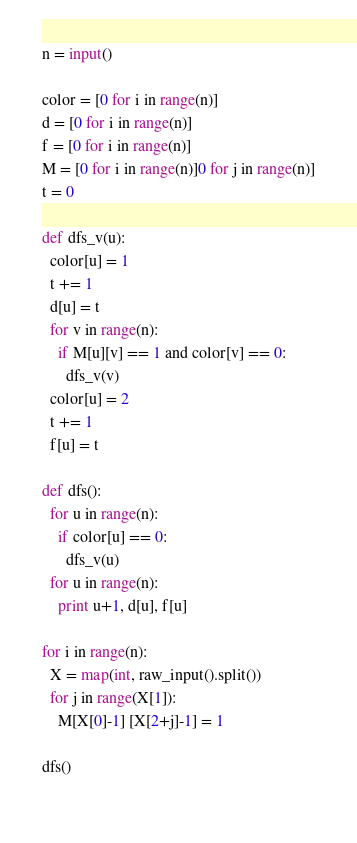Convert code to text. <code><loc_0><loc_0><loc_500><loc_500><_Python_>n = input()

color = [0 for i in range(n)]
d = [0 for i in range(n)]
f = [0 for i in range(n)]
M = [0 for i in range(n)]0 for j in range(n)]
t = 0

def dfs_v(u):
  color[u] = 1
  t += 1
  d[u] = t
  for v in range(n):
    if M[u][v] == 1 and color[v] == 0:
      dfs_v(v)
  color[u] = 2
  t += 1
  f[u] = t

def dfs():
  for u in range(n):
    if color[u] == 0:
      dfs_v(u)
  for u in range(n):
    print u+1, d[u], f[u]

for i in range(n):
  X = map(int, raw_input().split())
  for j in range(X[1]):
    M[X[0]-1] [X[2+j]-1] = 1

dfs()
    </code> 